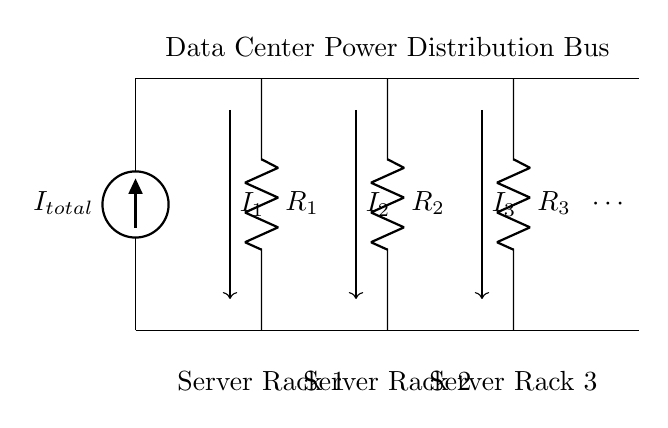What is the total current entering the circuit? The total current entering the circuit is represented by the current source labeled as I_total, which is the main input for the current divider circuit.
Answer: I_total How many server racks are represented in the circuit? The circuit diagram shows three server racks represented by R_1, R_2, and R_3. Additionally, an ellipsis indicates that there may be more racks not shown.
Answer: Three What are the voltage levels at the bus? The circuit indicates that there is a bus at the top and a ground line at the bottom. Thus, the voltage level of the bus is the source voltage, while the bottom is zero volts (ground).
Answer: Source voltage and zero volts If the resistances of R_1, R_2, and R_3 are equal, how does the total current divide? In a current divider with equal resistances, the current divides equally among the parallel branches. Since they are equal, each rack receives one-third of the total current I_total.
Answer: Equally What happens to the total current when a new server rack with identical resistance is added? Adding another identical resistance in parallel decreases the overall resistance of the circuit, which results in an increase in the total current supplied by the source due to the reduced load.
Answer: Increases total current What is the significance of the arrows indicating current directions? The arrows in the circuit diagram illustrate the flow of current from the source through each resistor, showing how the total current splits among each server rack, which is crucial for understanding current distribution.
Answer: Indicates current flow 